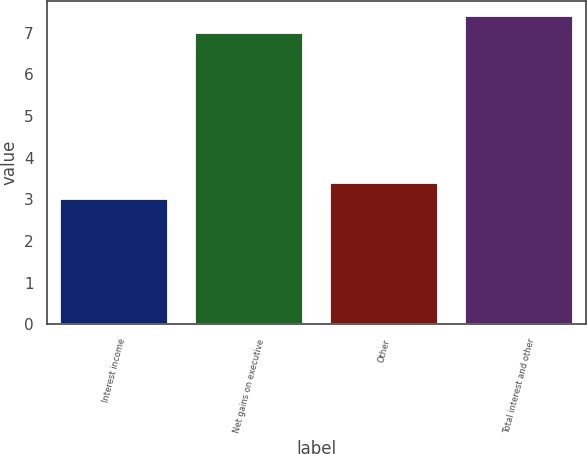Convert chart to OTSL. <chart><loc_0><loc_0><loc_500><loc_500><bar_chart><fcel>Interest income<fcel>Net gains on executive<fcel>Other<fcel>Total interest and other<nl><fcel>3<fcel>7<fcel>3.4<fcel>7.4<nl></chart> 